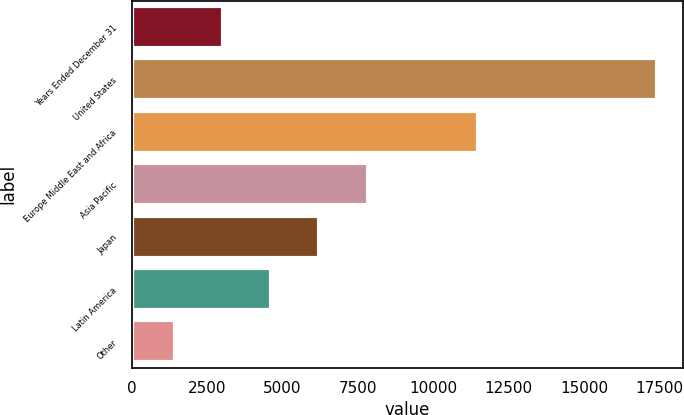Convert chart. <chart><loc_0><loc_0><loc_500><loc_500><bar_chart><fcel>Years Ended December 31<fcel>United States<fcel>Europe Middle East and Africa<fcel>Asia Pacific<fcel>Japan<fcel>Latin America<fcel>Other<nl><fcel>3022.2<fcel>17424<fcel>11478<fcel>7822.8<fcel>6222.6<fcel>4622.4<fcel>1422<nl></chart> 